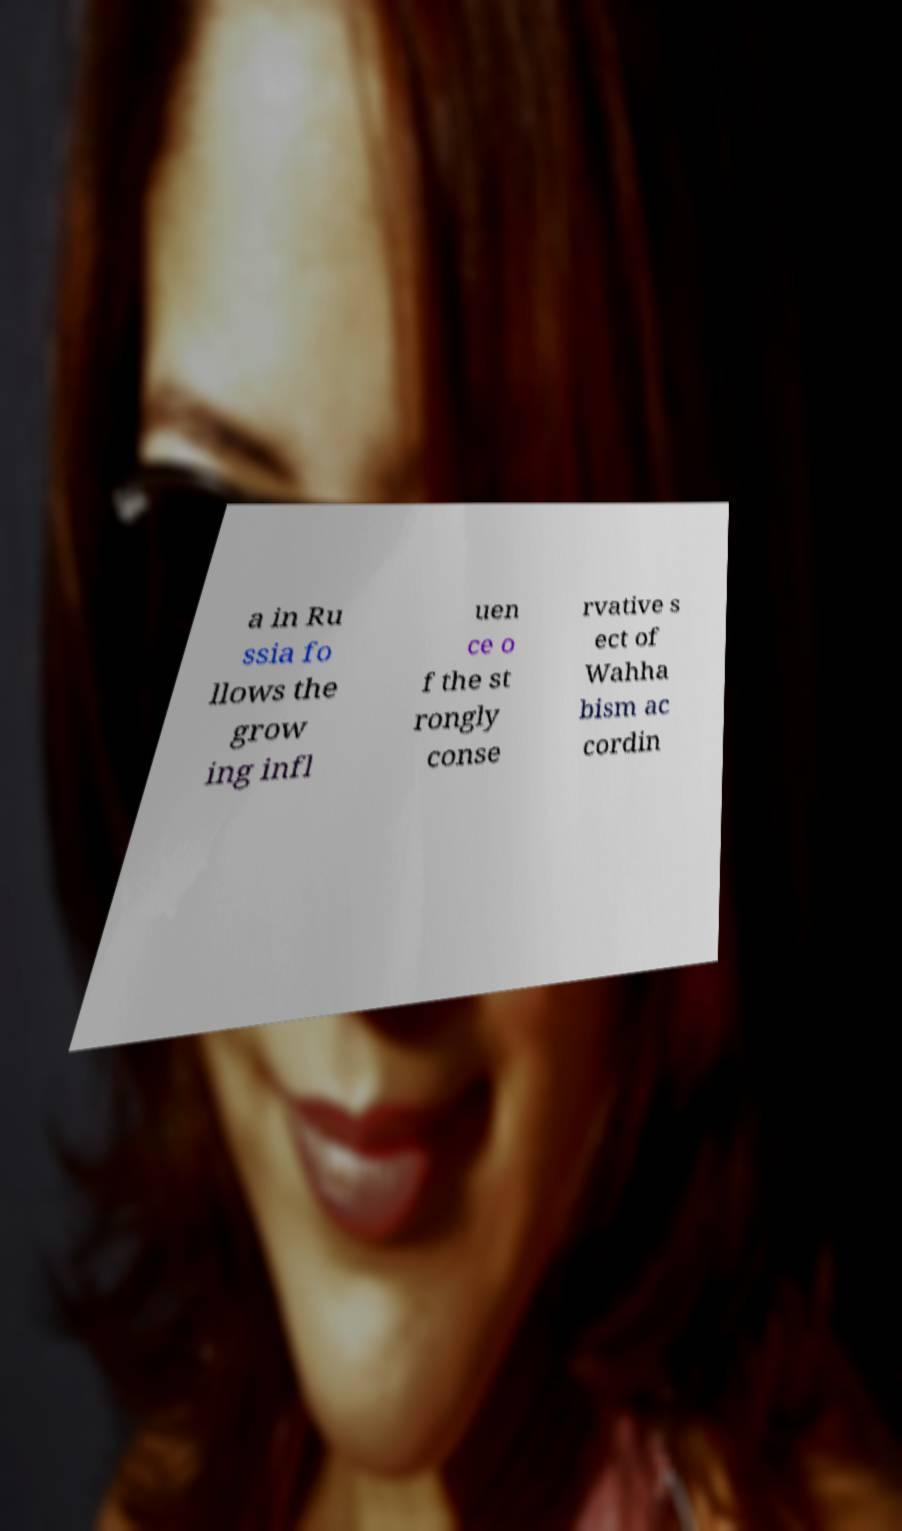Can you accurately transcribe the text from the provided image for me? a in Ru ssia fo llows the grow ing infl uen ce o f the st rongly conse rvative s ect of Wahha bism ac cordin 